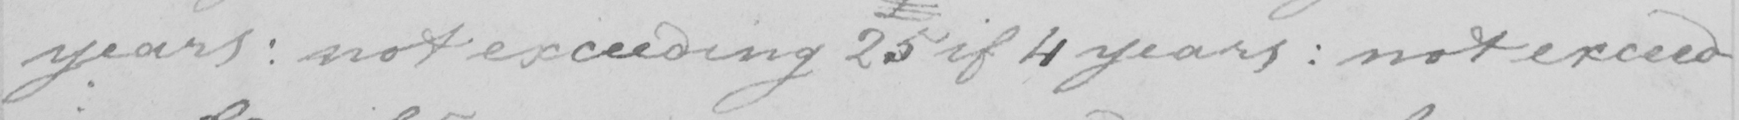Please transcribe the handwritten text in this image. years :  not exceeding 25 if 4 years  :  not exceed- 